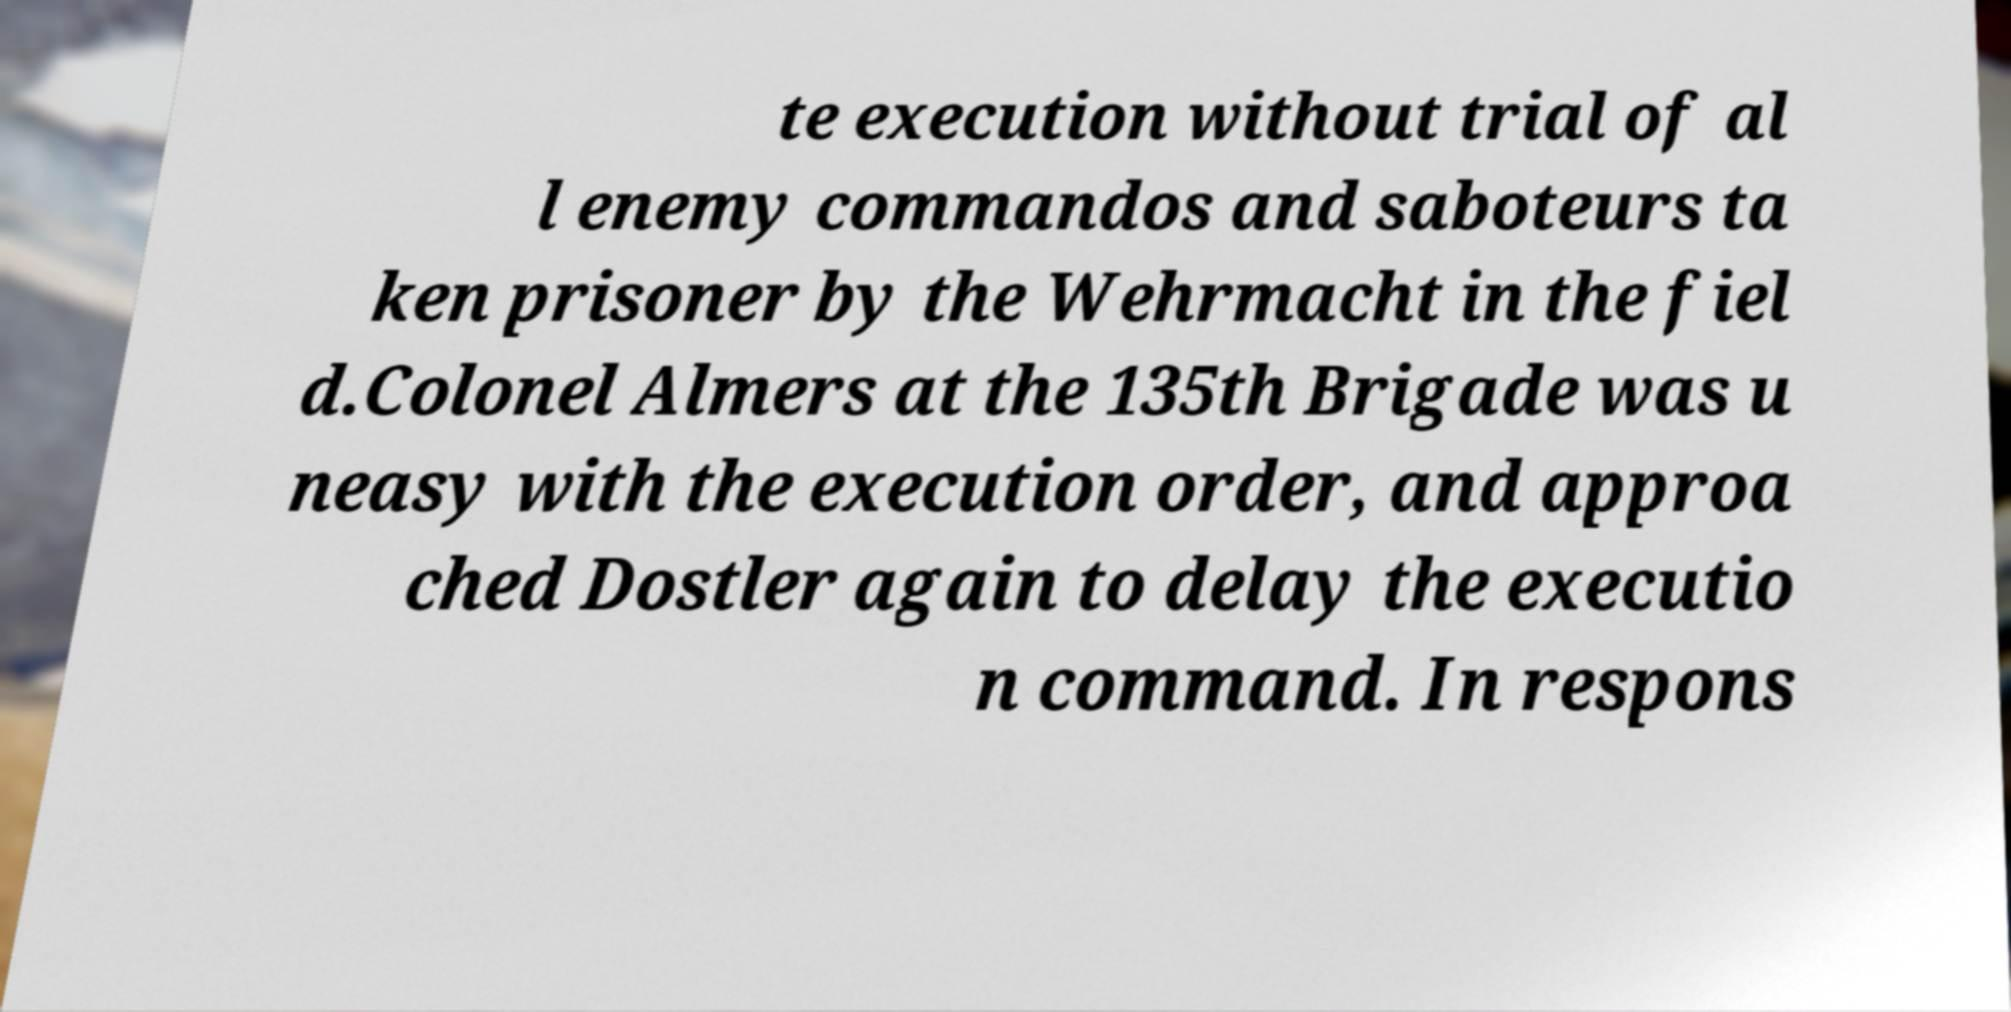Please read and relay the text visible in this image. What does it say? te execution without trial of al l enemy commandos and saboteurs ta ken prisoner by the Wehrmacht in the fiel d.Colonel Almers at the 135th Brigade was u neasy with the execution order, and approa ched Dostler again to delay the executio n command. In respons 